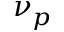Convert formula to latex. <formula><loc_0><loc_0><loc_500><loc_500>\nu _ { p }</formula> 